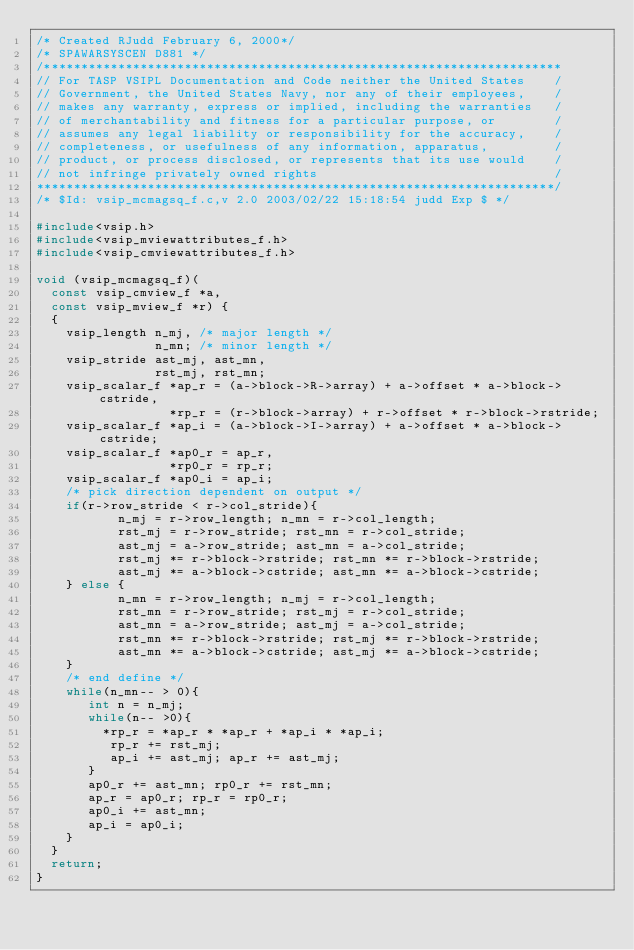Convert code to text. <code><loc_0><loc_0><loc_500><loc_500><_C_>/* Created RJudd February 6, 2000*/
/* SPAWARSYSCEN D881 */
/**********************************************************************
// For TASP VSIPL Documentation and Code neither the United States    /
// Government, the United States Navy, nor any of their employees,    /
// makes any warranty, express or implied, including the warranties   /
// of merchantability and fitness for a particular purpose, or        /
// assumes any legal liability or responsibility for the accuracy,    /
// completeness, or usefulness of any information, apparatus,         /
// product, or process disclosed, or represents that its use would    /
// not infringe privately owned rights                                /
**********************************************************************/
/* $Id: vsip_mcmagsq_f.c,v 2.0 2003/02/22 15:18:54 judd Exp $ */

#include<vsip.h>
#include<vsip_mviewattributes_f.h>
#include<vsip_cmviewattributes_f.h>

void (vsip_mcmagsq_f)(
  const vsip_cmview_f *a,
  const vsip_mview_f *r) {
  { 
    vsip_length n_mj, /* major length */
                n_mn; /* minor length */
    vsip_stride ast_mj, ast_mn,
                rst_mj, rst_mn;
    vsip_scalar_f *ap_r = (a->block->R->array) + a->offset * a->block->cstride,
                  *rp_r = (r->block->array) + r->offset * r->block->rstride;
    vsip_scalar_f *ap_i = (a->block->I->array) + a->offset * a->block->cstride;
    vsip_scalar_f *ap0_r = ap_r,
                  *rp0_r = rp_r;
    vsip_scalar_f *ap0_i = ap_i;
    /* pick direction dependent on output */
    if(r->row_stride < r->col_stride){
           n_mj = r->row_length; n_mn = r->col_length;
           rst_mj = r->row_stride; rst_mn = r->col_stride;
           ast_mj = a->row_stride; ast_mn = a->col_stride;
           rst_mj *= r->block->rstride; rst_mn *= r->block->rstride;
           ast_mj *= a->block->cstride; ast_mn *= a->block->cstride;
    } else {
           n_mn = r->row_length; n_mj = r->col_length;
           rst_mn = r->row_stride; rst_mj = r->col_stride;
           ast_mn = a->row_stride; ast_mj = a->col_stride;
           rst_mn *= r->block->rstride; rst_mj *= r->block->rstride;
           ast_mn *= a->block->cstride; ast_mj *= a->block->cstride;
    }
    /* end define */
    while(n_mn-- > 0){
       int n = n_mj;
       while(n-- >0){
         *rp_r = *ap_r * *ap_r + *ap_i * *ap_i;
          rp_r += rst_mj;
          ap_i += ast_mj; ap_r += ast_mj;
       }
       ap0_r += ast_mn; rp0_r += rst_mn;
       ap_r = ap0_r; rp_r = rp0_r;
       ap0_i += ast_mn; 
       ap_i = ap0_i; 
    }
  }
  return;
}
</code> 